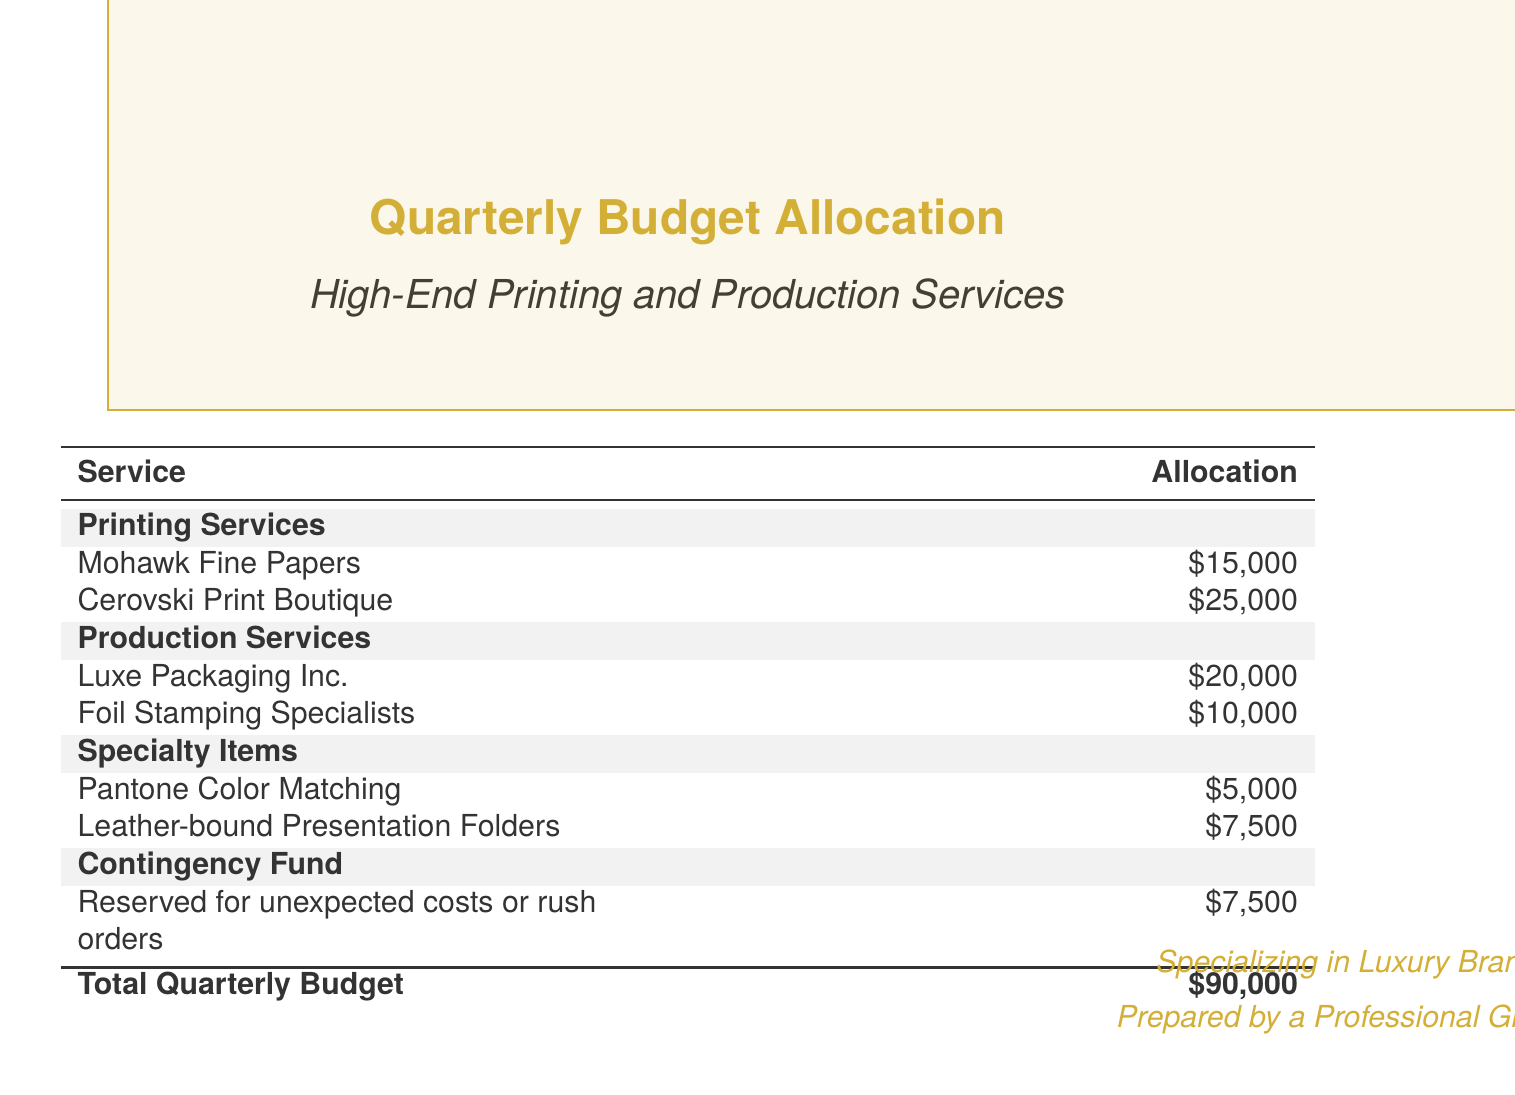What is the total quarterly budget? The total quarterly budget is stated at the bottom of the table, calculated from the allocations listed above.
Answer: $90,000 How much is allocated to Mohawk Fine Papers? The document specifies the allocation for Mohawk Fine Papers under Printing Services.
Answer: $15,000 Which company has the highest allocation? By comparing the allocations listed in the document, the company with the highest allocation is identified.
Answer: Cerovski Print Boutique What percentage of the total budget is allocated to Production Services? The allocation for Production Services is $30,000. The percentage is calculated by dividing this by the total budget and multiplying by 100.
Answer: 33.33% What is the purpose of the contingency fund? The document describes the contingency fund as reserved for certain unexpected costs.
Answer: Unexpected costs or rush orders How much is allocated to specialty items? The document lists the individual allocations for specialty items and a total can be determined by summing these.
Answer: $12,500 Which service has the lowest budget allocation? Reviewing the service allocations in the document identifies which service receives the least funding.
Answer: Pantone Color Matching What color theme is used in the document? The document utilizes a gold color palette for headings, indicated in the color definitions at the beginning.
Answer: Gold How many printing services are listed? By counting the entries under the Printing Services section, the total is determined.
Answer: 2 